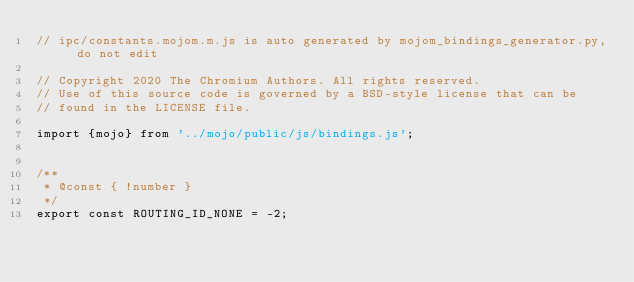Convert code to text. <code><loc_0><loc_0><loc_500><loc_500><_JavaScript_>// ipc/constants.mojom.m.js is auto generated by mojom_bindings_generator.py, do not edit

// Copyright 2020 The Chromium Authors. All rights reserved.
// Use of this source code is governed by a BSD-style license that can be
// found in the LICENSE file.

import {mojo} from '../mojo/public/js/bindings.js';


/**
 * @const { !number }
 */
export const ROUTING_ID_NONE = -2;




</code> 